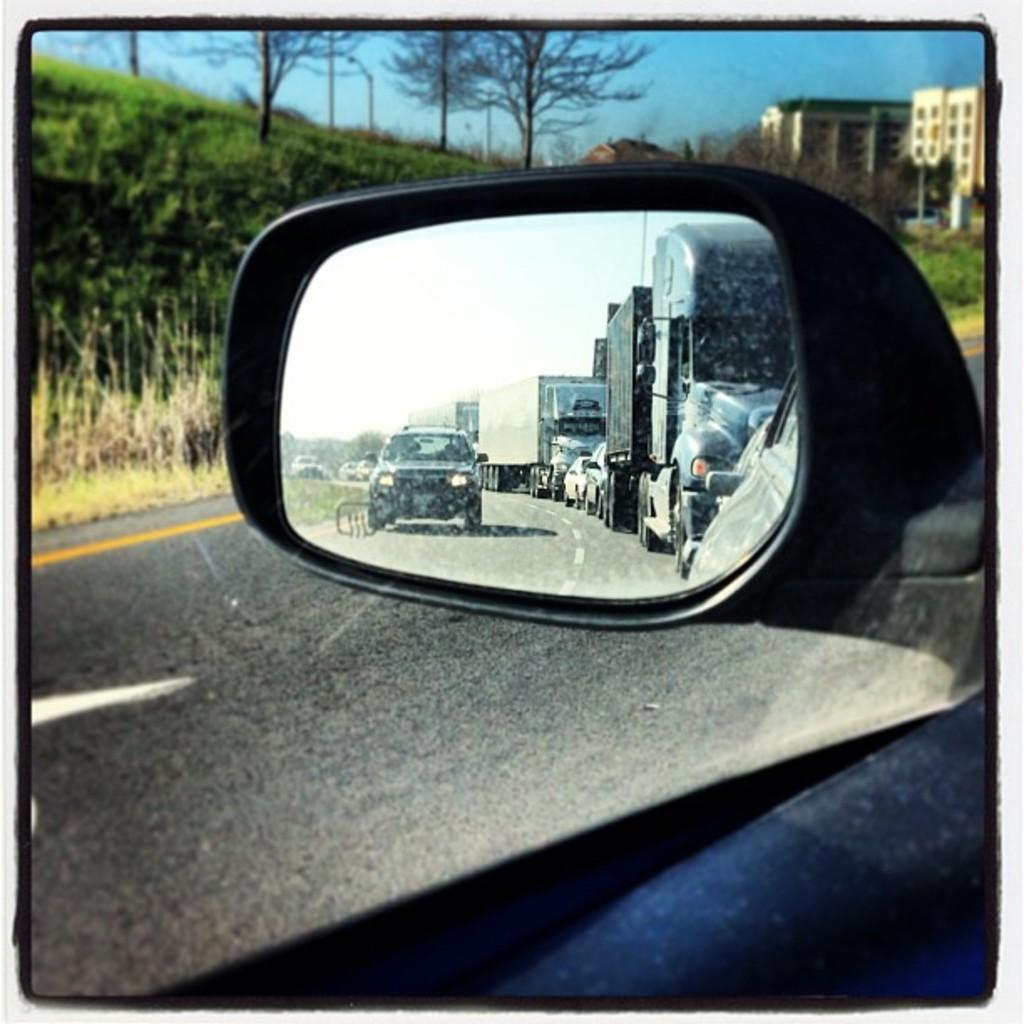Could you give a brief overview of what you see in this image? In this picture in the foreground there is one car and mirror, in the background there are some trees and buildings, at the bottom there is a road. On the top of the image there is sky. 